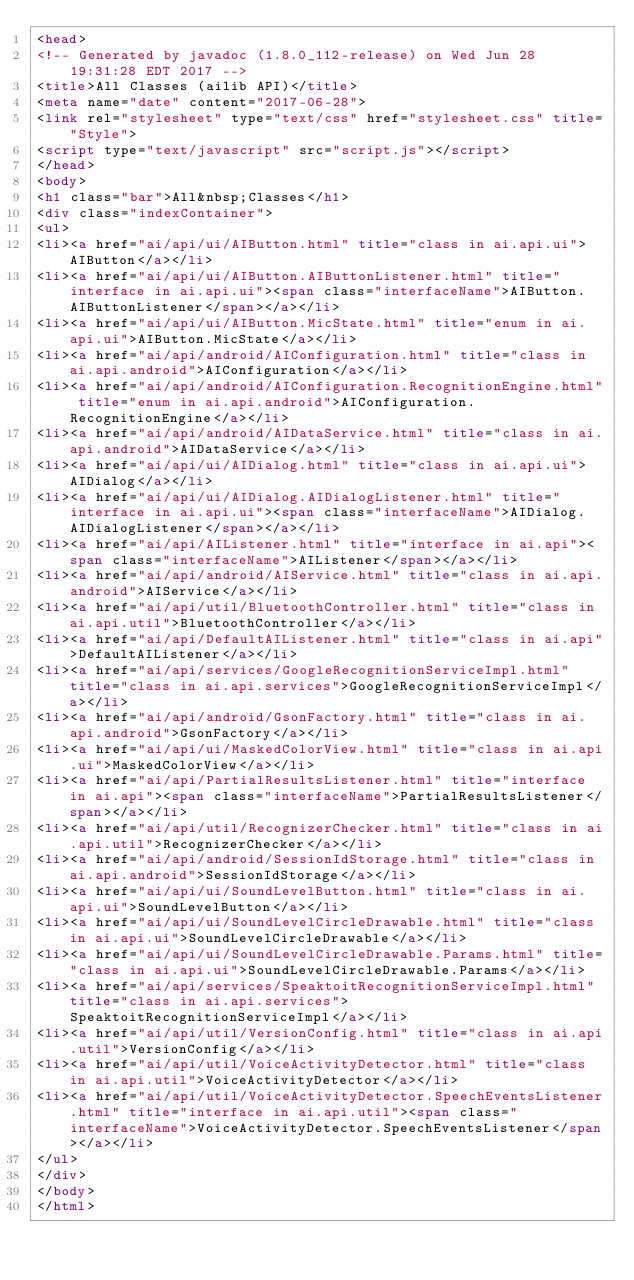<code> <loc_0><loc_0><loc_500><loc_500><_HTML_><head>
<!-- Generated by javadoc (1.8.0_112-release) on Wed Jun 28 19:31:28 EDT 2017 -->
<title>All Classes (ailib API)</title>
<meta name="date" content="2017-06-28">
<link rel="stylesheet" type="text/css" href="stylesheet.css" title="Style">
<script type="text/javascript" src="script.js"></script>
</head>
<body>
<h1 class="bar">All&nbsp;Classes</h1>
<div class="indexContainer">
<ul>
<li><a href="ai/api/ui/AIButton.html" title="class in ai.api.ui">AIButton</a></li>
<li><a href="ai/api/ui/AIButton.AIButtonListener.html" title="interface in ai.api.ui"><span class="interfaceName">AIButton.AIButtonListener</span></a></li>
<li><a href="ai/api/ui/AIButton.MicState.html" title="enum in ai.api.ui">AIButton.MicState</a></li>
<li><a href="ai/api/android/AIConfiguration.html" title="class in ai.api.android">AIConfiguration</a></li>
<li><a href="ai/api/android/AIConfiguration.RecognitionEngine.html" title="enum in ai.api.android">AIConfiguration.RecognitionEngine</a></li>
<li><a href="ai/api/android/AIDataService.html" title="class in ai.api.android">AIDataService</a></li>
<li><a href="ai/api/ui/AIDialog.html" title="class in ai.api.ui">AIDialog</a></li>
<li><a href="ai/api/ui/AIDialog.AIDialogListener.html" title="interface in ai.api.ui"><span class="interfaceName">AIDialog.AIDialogListener</span></a></li>
<li><a href="ai/api/AIListener.html" title="interface in ai.api"><span class="interfaceName">AIListener</span></a></li>
<li><a href="ai/api/android/AIService.html" title="class in ai.api.android">AIService</a></li>
<li><a href="ai/api/util/BluetoothController.html" title="class in ai.api.util">BluetoothController</a></li>
<li><a href="ai/api/DefaultAIListener.html" title="class in ai.api">DefaultAIListener</a></li>
<li><a href="ai/api/services/GoogleRecognitionServiceImpl.html" title="class in ai.api.services">GoogleRecognitionServiceImpl</a></li>
<li><a href="ai/api/android/GsonFactory.html" title="class in ai.api.android">GsonFactory</a></li>
<li><a href="ai/api/ui/MaskedColorView.html" title="class in ai.api.ui">MaskedColorView</a></li>
<li><a href="ai/api/PartialResultsListener.html" title="interface in ai.api"><span class="interfaceName">PartialResultsListener</span></a></li>
<li><a href="ai/api/util/RecognizerChecker.html" title="class in ai.api.util">RecognizerChecker</a></li>
<li><a href="ai/api/android/SessionIdStorage.html" title="class in ai.api.android">SessionIdStorage</a></li>
<li><a href="ai/api/ui/SoundLevelButton.html" title="class in ai.api.ui">SoundLevelButton</a></li>
<li><a href="ai/api/ui/SoundLevelCircleDrawable.html" title="class in ai.api.ui">SoundLevelCircleDrawable</a></li>
<li><a href="ai/api/ui/SoundLevelCircleDrawable.Params.html" title="class in ai.api.ui">SoundLevelCircleDrawable.Params</a></li>
<li><a href="ai/api/services/SpeaktoitRecognitionServiceImpl.html" title="class in ai.api.services">SpeaktoitRecognitionServiceImpl</a></li>
<li><a href="ai/api/util/VersionConfig.html" title="class in ai.api.util">VersionConfig</a></li>
<li><a href="ai/api/util/VoiceActivityDetector.html" title="class in ai.api.util">VoiceActivityDetector</a></li>
<li><a href="ai/api/util/VoiceActivityDetector.SpeechEventsListener.html" title="interface in ai.api.util"><span class="interfaceName">VoiceActivityDetector.SpeechEventsListener</span></a></li>
</ul>
</div>
</body>
</html>
</code> 